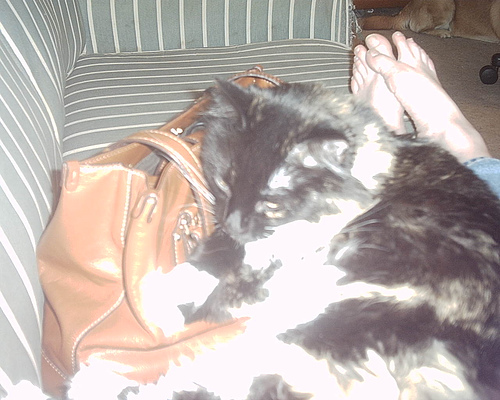What is the cat resting on? The cat is resting on a couch, next to a brown handbag. 